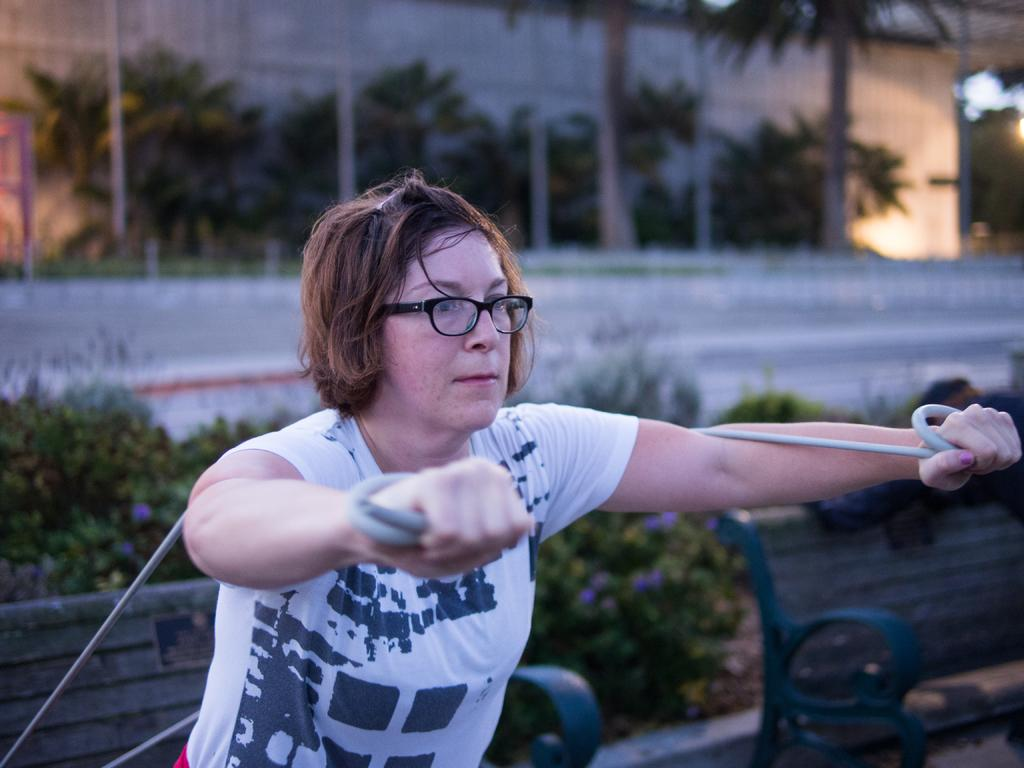What can be seen in the image? There is a person in the image. What is the person holding in the image? The person is holding an object. Can you describe the person's clothing? The person is wearing a white shirt. What can be seen in the background of the image? There are plants and trees in the background of the image. What is the color of the plants and trees? The plants and trees are green in color. How does the person wash the button in the image? There is no button present in the image, so the person cannot wash a button. 